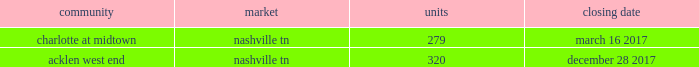2022 secondary market same store communities are generally communities in markets with populations of more than 1 million but less than 1% ( 1 % ) of the total public multifamily reit units or markets with populations of less than 1 million that we have owned and have been stabilized for at least a full 12 months .
2022 non-same store communities and other includes recent acquisitions , communities in development or lease-up , communities that have been identified for disposition , and communities that have undergone a significant casualty loss .
Also included in non-same store communities are non-multifamily activities .
On the first day of each calendar year , we determine the composition of our same store operating segments for that year as well as adjust the previous year , which allows us to evaluate full period-over-period operating comparisons .
An apartment community in development or lease-up is added to the same store portfolio on the first day of the calendar year after it has been owned and stabilized for at least a full 12 months .
Communities are considered stabilized after achieving 90% ( 90 % ) occupancy for 90 days .
Communities that have been identified for disposition are excluded from the same store portfolio .
All properties acquired from post properties in the merger remained in the non-same store and other operating segment during 2017 , as the properties were recent acquisitions and had not been owned and stabilized for at least 12 months as of january 1 , 2017 .
For additional information regarding our operating segments , see note 14 to the consolidated financial statements included elsewhere in this annual report on form 10-k .
Acquisitions one of our growth strategies is to acquire apartment communities that are located in various large or secondary markets primarily throughout the southeast and southwest regions of the united states .
Acquisitions , along with dispositions , help us achieve and maintain our desired product mix , geographic diversification and asset allocation .
Portfolio growth allows for maximizing the efficiency of the existing management and overhead structure .
We have extensive experience in the acquisition of multifamily communities .
We will continue to evaluate opportunities that arise , and we will utilize this strategy to increase our number of apartment communities in strong and growing markets .
We acquired the following apartment communities during the year ended december 31 , 2017: .
Dispositions we sell apartment communities and other assets that no longer meet our long-term strategy or when market conditions are favorable , and we redeploy the proceeds from those sales to acquire , develop and redevelop additional apartment communities and rebalance our portfolio across or within geographic regions .
Dispositions also allow us to realize a portion of the value created through our investments and provide additional liquidity .
We are then able to redeploy the net proceeds from our dispositions in lieu of raising additional capital .
In deciding to sell an apartment community , we consider current market conditions and generally solicit competing bids from unrelated parties for these individual assets , considering the sales price and other key terms of each proposal .
We also consider portfolio dispositions when such a structure is useful to maximize proceeds and efficiency of execution .
During the year ended december 31 , 2017 , we disposed of five multifamily properties totaling 1760 units and four land parcels totaling approximately 23 acres .
Development as another part of our growth strategy , we invest in a limited number of development projects .
Development activities may be conducted through wholly-owned affiliated companies or through joint ventures with unaffiliated parties .
Fixed price construction contracts are signed with unrelated parties to minimize construction risk .
We typically manage the leasing portion of the project as units become available for lease .
We may also engage in limited expansion development opportunities on existing communities in which we typically serve as the developer .
While we seek opportunistic new development investments offering attractive long-term investment returns , we intend to maintain a total development commitment that we consider modest in relation to our total balance sheet and investment portfolio .
During the year ended december 31 , 2017 , we incurred $ 170.1 million in development costs and completed 7 development projects. .
What is the number of units necessary to stabilize the acklen west end community? 
Rationale: it is the minimum percentage of 90% multiplied by the number of units .
Computations: (90% * 320)
Answer: 288.0. 